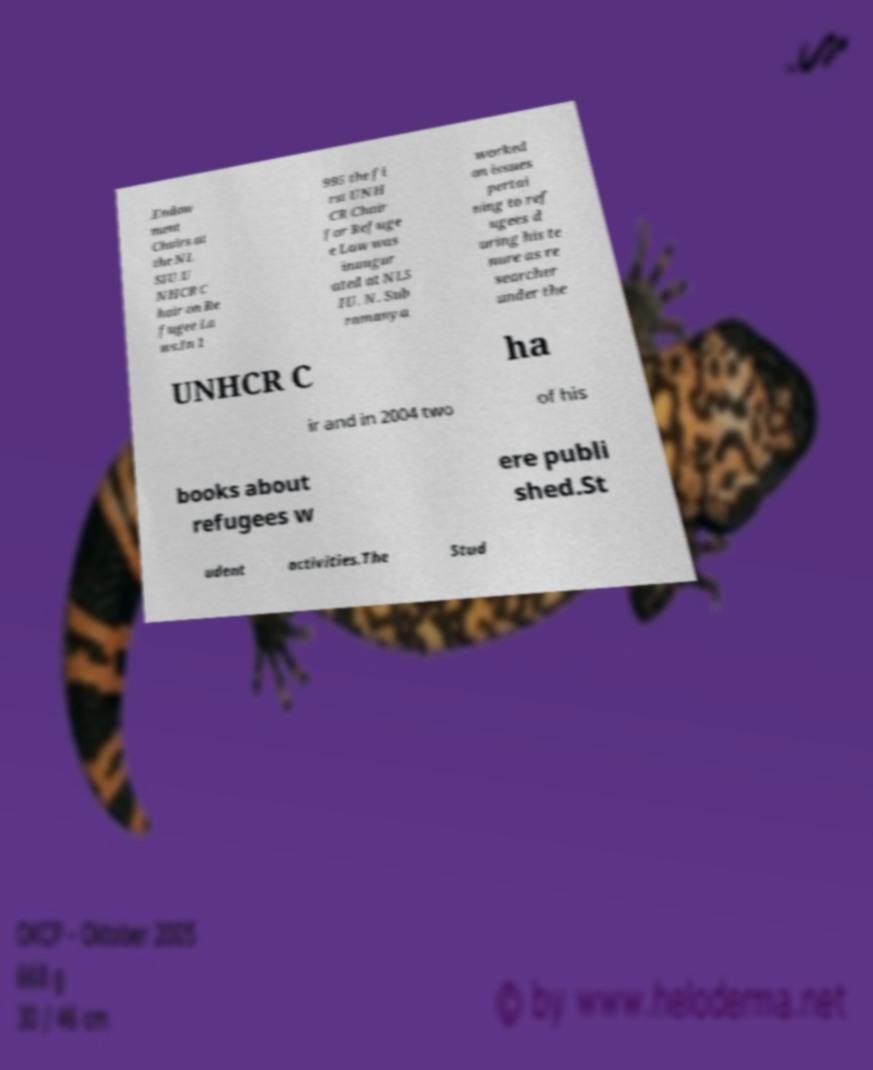There's text embedded in this image that I need extracted. Can you transcribe it verbatim? .Endow ment Chairs at the NL SIU.U NHCR C hair on Re fugee La ws.In 1 995 the fi rst UNH CR Chair for Refuge e Law was inaugur ated at NLS IU. N. Sub ramanya worked on issues pertai ning to ref ugees d uring his te nure as re searcher under the UNHCR C ha ir and in 2004 two of his books about refugees w ere publi shed.St udent activities.The Stud 